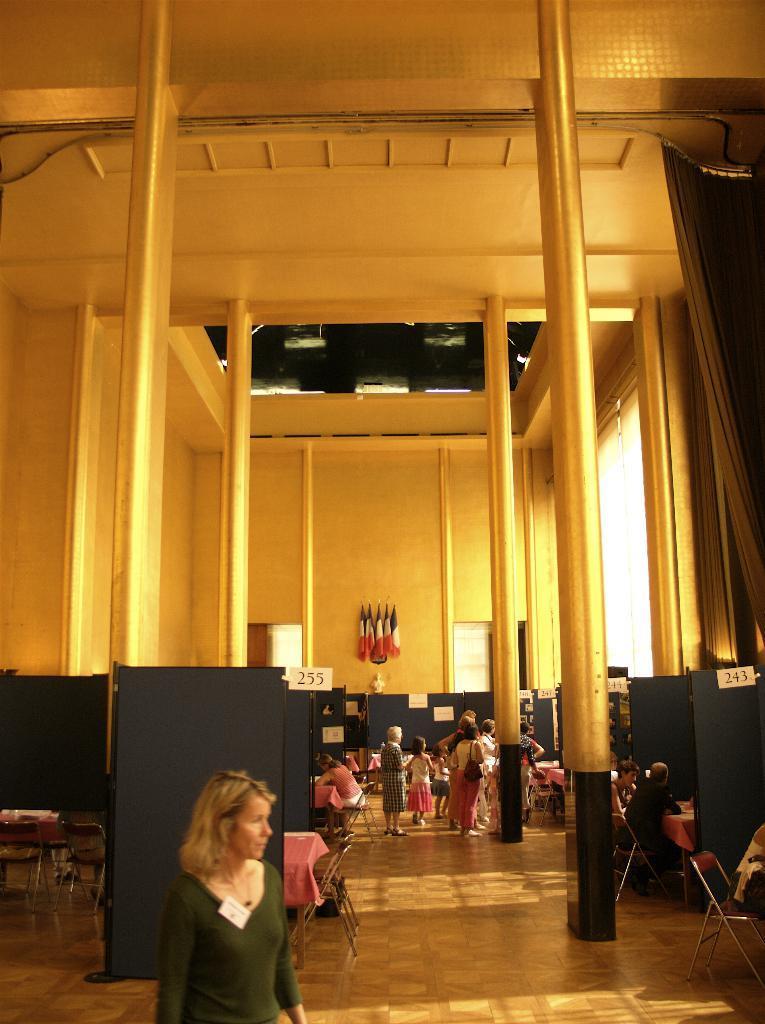Describe this image in one or two sentences. In the foreground of the picture there is a woman and there are chairs and boards. In the center of the picture there are pillars, people and desk. In the background there are flags, wall and other objects. At the top it is ceiling. 